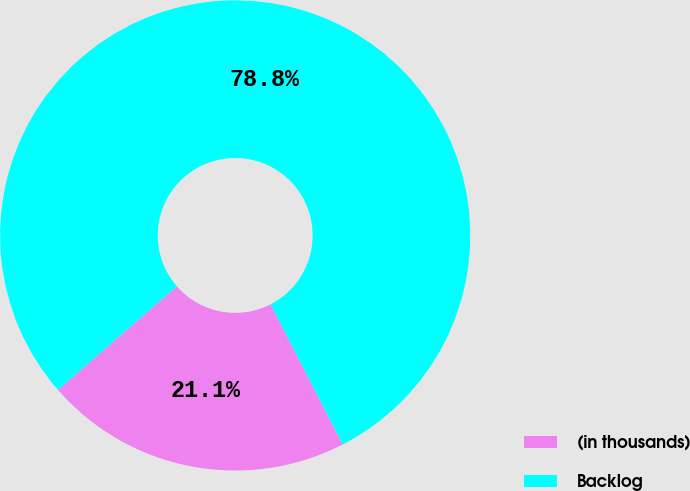Convert chart. <chart><loc_0><loc_0><loc_500><loc_500><pie_chart><fcel>(in thousands)<fcel>Backlog<nl><fcel>21.15%<fcel>78.85%<nl></chart> 